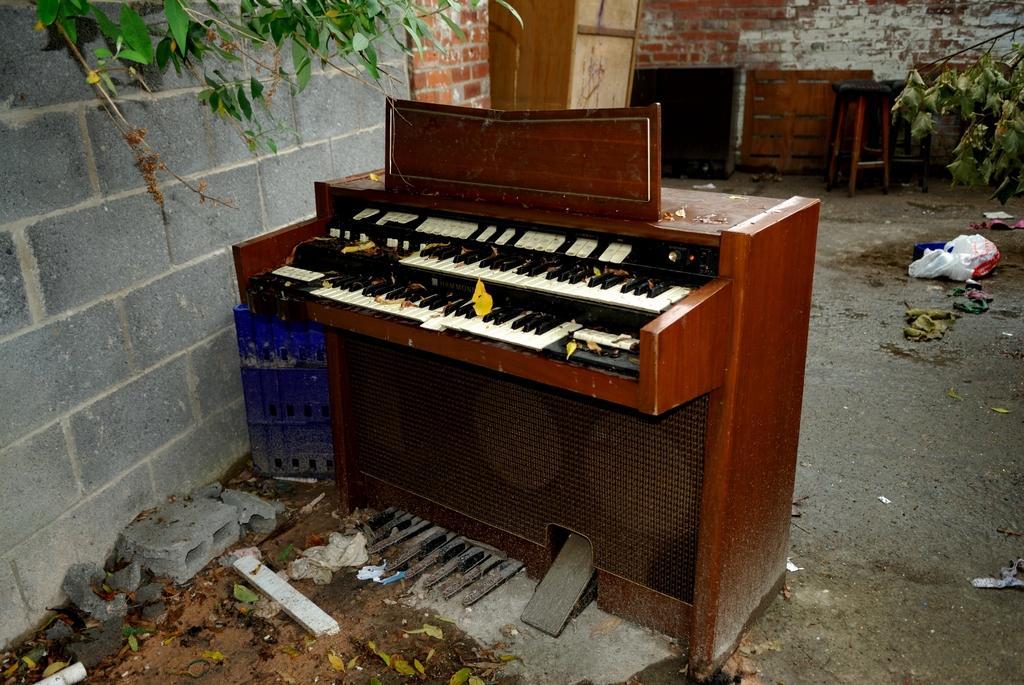Describe this image in one or two sentences. In the image there is a keyboard filled with some dust particles. On left side there is a wall we can also see a tree with some green leaves. In middle there is a brick wall. On right side we can also see a tree with green leaves on bottom we can see a polythene cover and some clothes. 